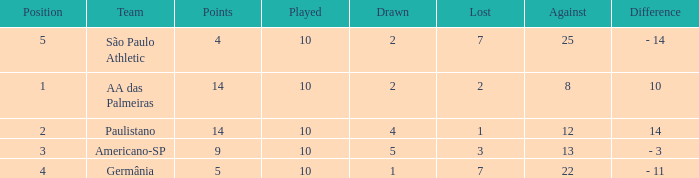What is the sum of Against when the lost is more than 7? None. 